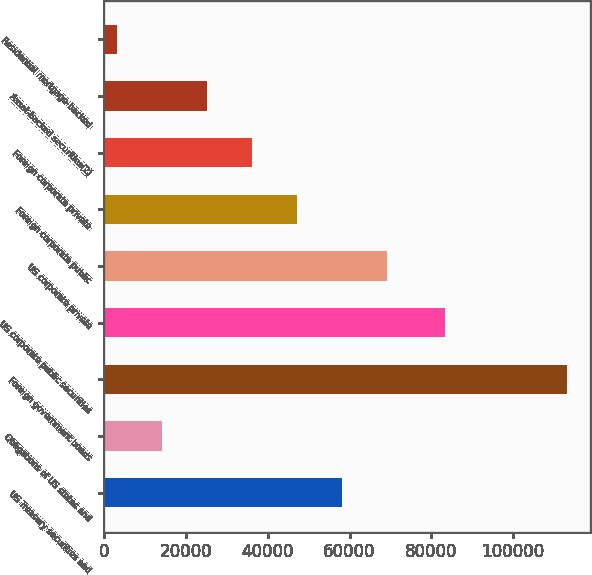Convert chart. <chart><loc_0><loc_0><loc_500><loc_500><bar_chart><fcel>US Treasury securities and<fcel>Obligations of US states and<fcel>Foreign government bonds<fcel>US corporate public securities<fcel>US corporate private<fcel>Foreign corporate public<fcel>Foreign corporate private<fcel>Asset-backed securities(2)<fcel>Residential mortgage-backed<nl><fcel>58057<fcel>14014.6<fcel>113110<fcel>83415<fcel>69067.6<fcel>47046.4<fcel>36035.8<fcel>25025.2<fcel>3004<nl></chart> 